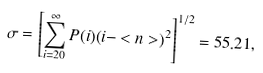Convert formula to latex. <formula><loc_0><loc_0><loc_500><loc_500>\sigma = \left [ \sum _ { i = 2 0 } ^ { \infty } P ( i ) ( i - < n > ) ^ { 2 } \right ] ^ { 1 / 2 } = 5 5 . 2 1 ,</formula> 